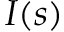Convert formula to latex. <formula><loc_0><loc_0><loc_500><loc_500>I ( s )</formula> 